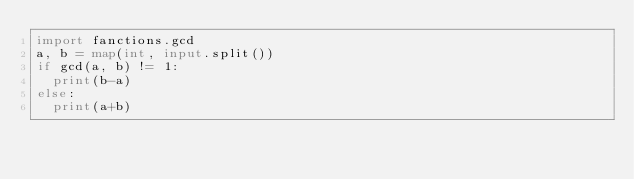Convert code to text. <code><loc_0><loc_0><loc_500><loc_500><_Python_>import fanctions.gcd
a, b = map(int, input.split())
if gcd(a, b) != 1:
  print(b-a)
else:
  print(a+b)</code> 